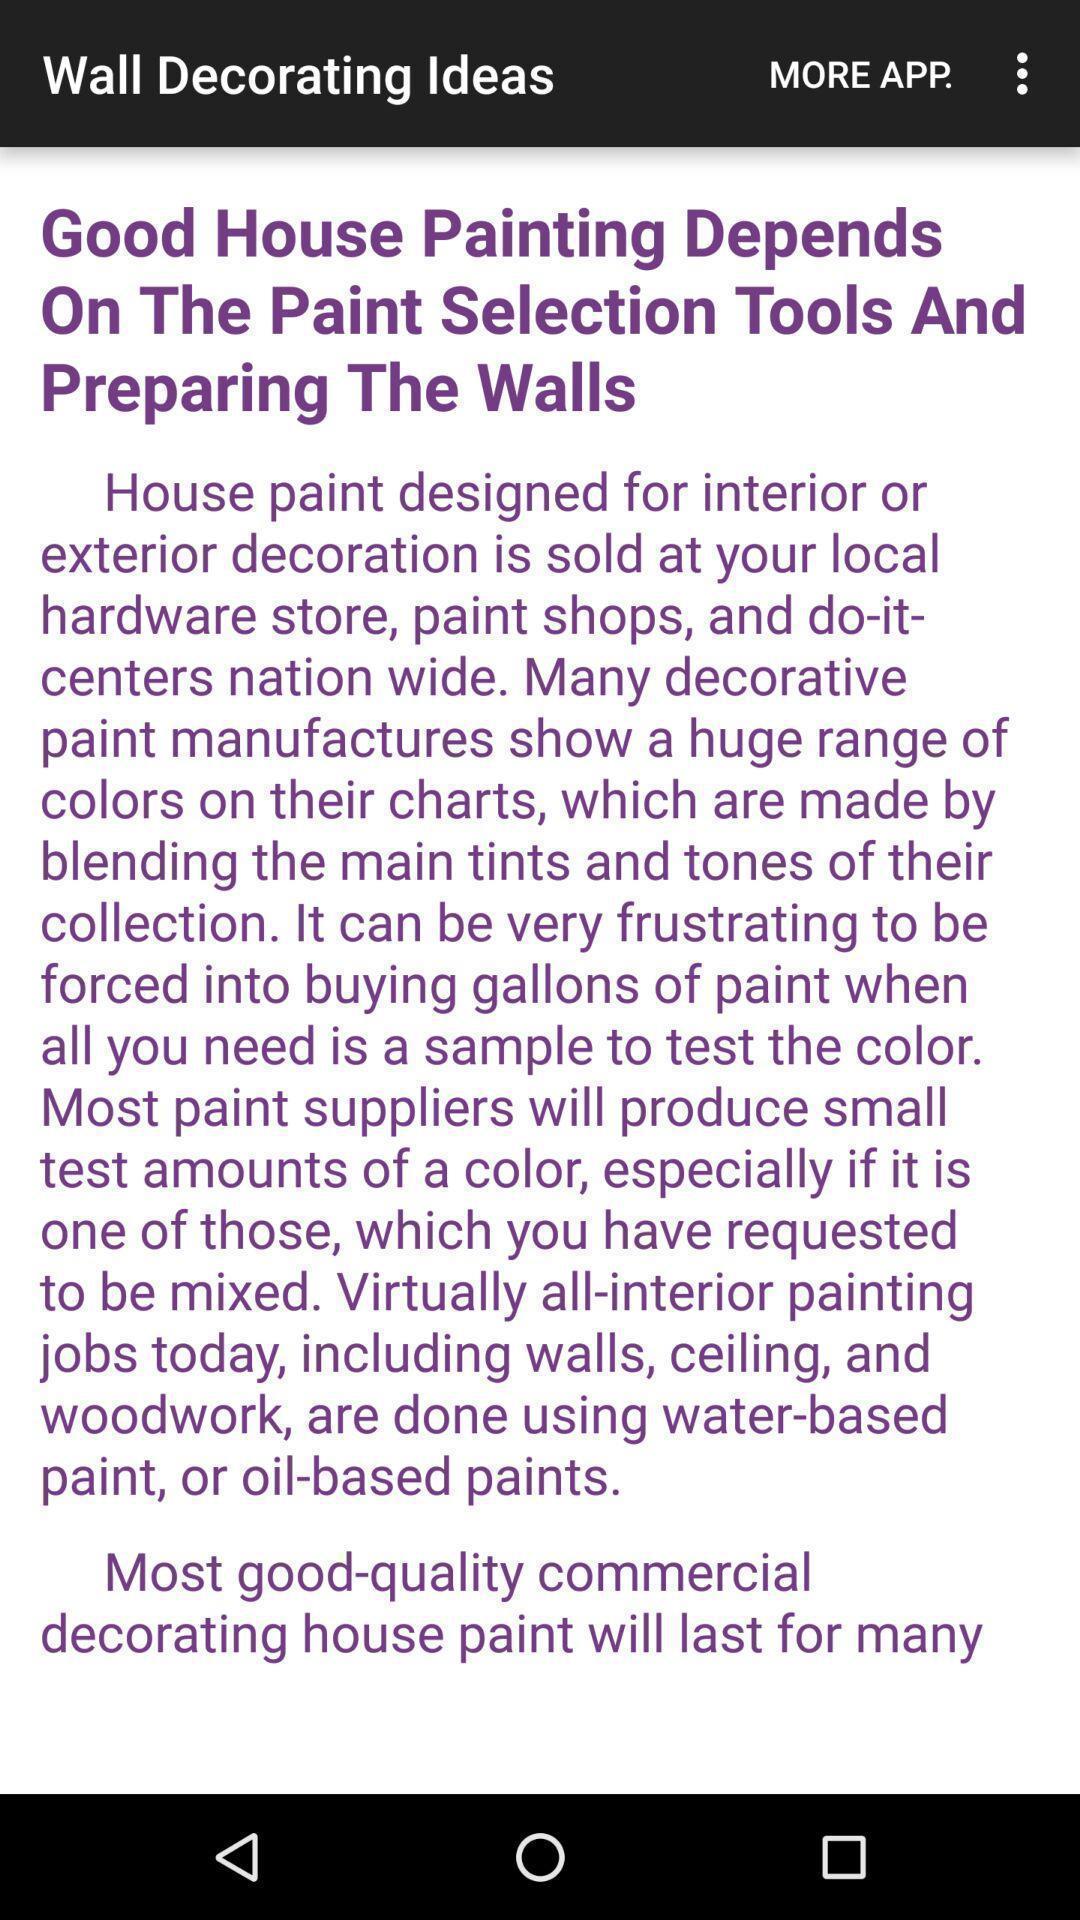Describe this image in words. Page showing house painting ideas. 